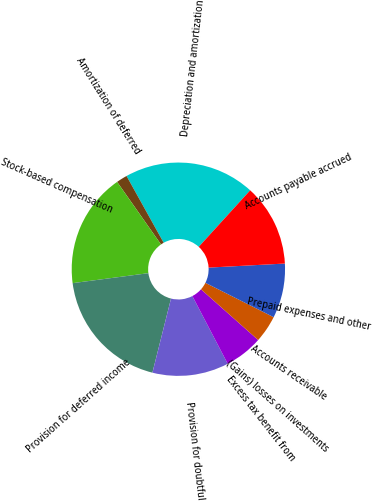Convert chart. <chart><loc_0><loc_0><loc_500><loc_500><pie_chart><fcel>Depreciation and amortization<fcel>Amortization of deferred<fcel>Stock-based compensation<fcel>Provision for deferred income<fcel>Provision for doubtful<fcel>Excess tax benefit from<fcel>(Gains) losses on investments<fcel>Accounts receivable<fcel>Prepaid expenses and other<fcel>Accounts payable accrued<nl><fcel>19.83%<fcel>1.66%<fcel>17.35%<fcel>19.0%<fcel>11.57%<fcel>5.79%<fcel>0.0%<fcel>4.13%<fcel>8.27%<fcel>12.4%<nl></chart> 